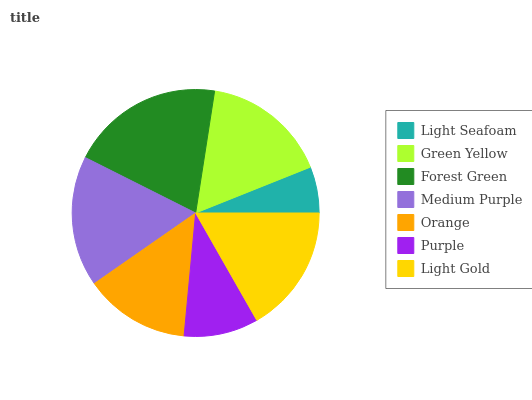Is Light Seafoam the minimum?
Answer yes or no. Yes. Is Forest Green the maximum?
Answer yes or no. Yes. Is Green Yellow the minimum?
Answer yes or no. No. Is Green Yellow the maximum?
Answer yes or no. No. Is Green Yellow greater than Light Seafoam?
Answer yes or no. Yes. Is Light Seafoam less than Green Yellow?
Answer yes or no. Yes. Is Light Seafoam greater than Green Yellow?
Answer yes or no. No. Is Green Yellow less than Light Seafoam?
Answer yes or no. No. Is Green Yellow the high median?
Answer yes or no. Yes. Is Green Yellow the low median?
Answer yes or no. Yes. Is Medium Purple the high median?
Answer yes or no. No. Is Purple the low median?
Answer yes or no. No. 